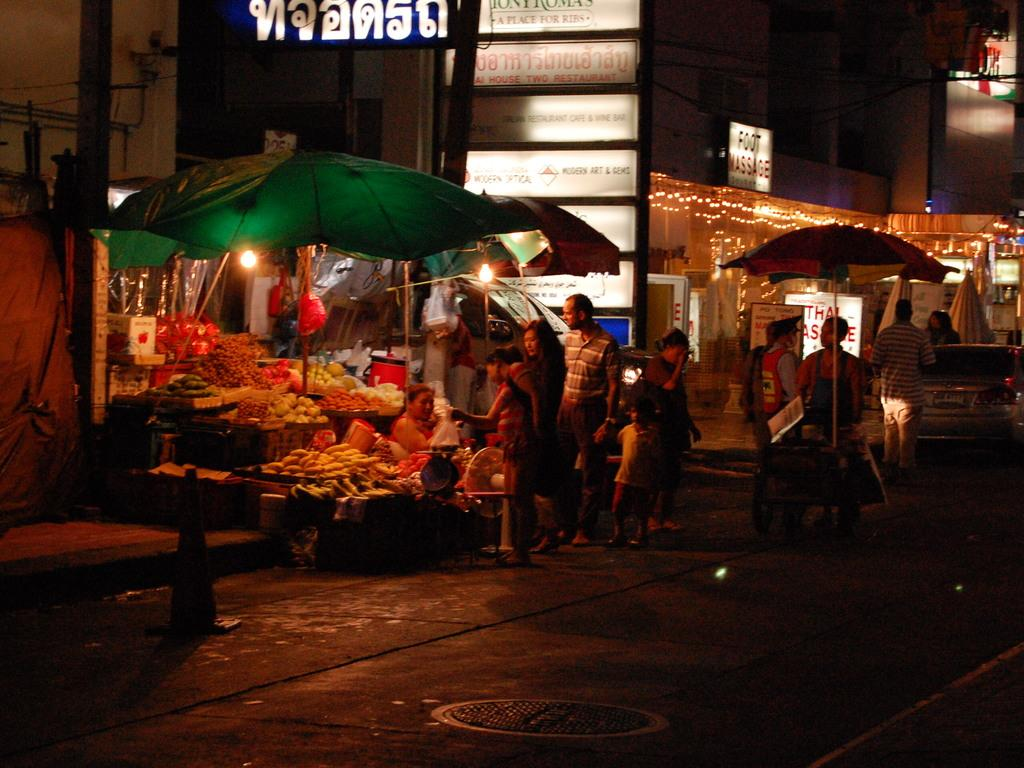What type of structures can be seen in the image? There are buildings in the image. What additional decorations are present in the image? There are banners in the image. What can be seen illuminating the scene? There are lights in the image. What objects are providing shelter or shade in the image? There are umbrellas in the image. Can you describe the gathering of people in the image? There is a group of people in the image. What type of food items are visible in the image? There are vegetables in the image. How would you describe the overall lighting in the image? The image is a little dark. How many grapes are hanging from the banners in the image? There are no grapes present in the image; only banners, buildings, lights, umbrellas, a group of people, vegetables, and a darker lighting can be observed. What color is the balloon floating above the group of people in the image? There is no balloon present in the image; only the mentioned subjects and objects can be observed. 